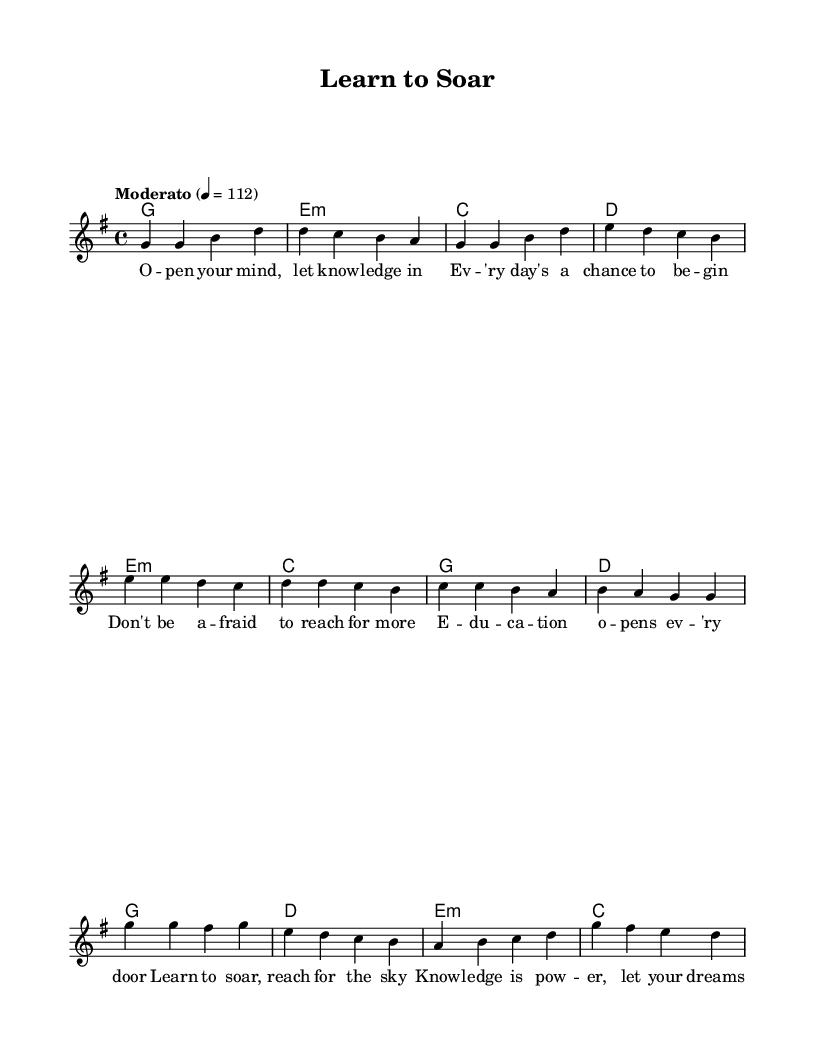What is the key signature of this music? The key signature is G major, which has one sharp (F#). You can identify the key signature by looking at the beginning of the staff, where it indicates the key notes with sharps or flats.
Answer: G major What is the time signature of this music? The time signature is 4/4, which can be found at the beginning of the sheet music. It indicates that there are four beats in each measure and the quarter note receives one beat.
Answer: 4/4 What is the tempo marking for this piece? The tempo marking states "Moderato" with a metronome marking of 112. This indicates a moderate speed for the piece, and the number corresponds to the bpm (beats per minute).
Answer: Moderato, 112 How many measures are in the verse? There are four measures in the verse. This is determined by counting the groups separated by vertical lines (bar lines) that consist of the melody and harmonies in the verse section.
Answer: 4 What is the last note of the chorus melody? The last note of the chorus melody is D. You can find this by observing the melody line for the chorus section, looking at the last notation in that grouping.
Answer: D Which chord is played during the second measure of the verse? The chord in the second measure of the verse is E minor. This can be seen on the chord staff directly above the melody line, indicating the harmony played alongside the melody.
Answer: E minor What theme does the lyrics of this piece primarily convey? The theme conveyed in the lyrics is about education and empowerment. The words focus on knowledge and the importance of reaching for more, aligning with the idea of lifelong learning.
Answer: Education and empowerment 